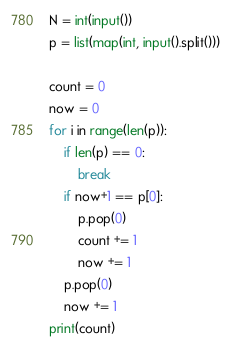Convert code to text. <code><loc_0><loc_0><loc_500><loc_500><_Python_>N = int(input())
p = list(map(int, input().split()))

count = 0
now = 0
for i in range(len(p)):
    if len(p) == 0:
        break
    if now+1 == p[0]:
        p.pop(0)
        count += 1
        now += 1
    p.pop(0)
    now += 1
print(count)
</code> 